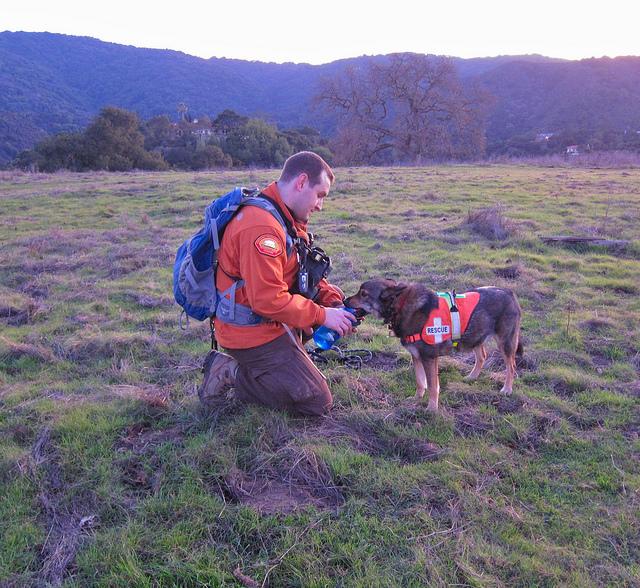Is the man in the picture happy?
Short answer required. Yes. What is the dog wearing?
Quick response, please. Vest. What type of dog is this?
Concise answer only. Rescue dog. What color is the man's shirt?
Give a very brief answer. Orange. How many people are shown?
Answer briefly. 1. What is in the container the person is holding?
Be succinct. Water. Is this ground flat?
Give a very brief answer. Yes. 